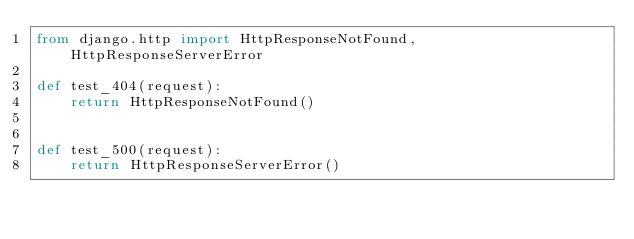Convert code to text. <code><loc_0><loc_0><loc_500><loc_500><_Python_>from django.http import HttpResponseNotFound, HttpResponseServerError

def test_404(request):
    return HttpResponseNotFound()


def test_500(request):
    return HttpResponseServerError()
</code> 